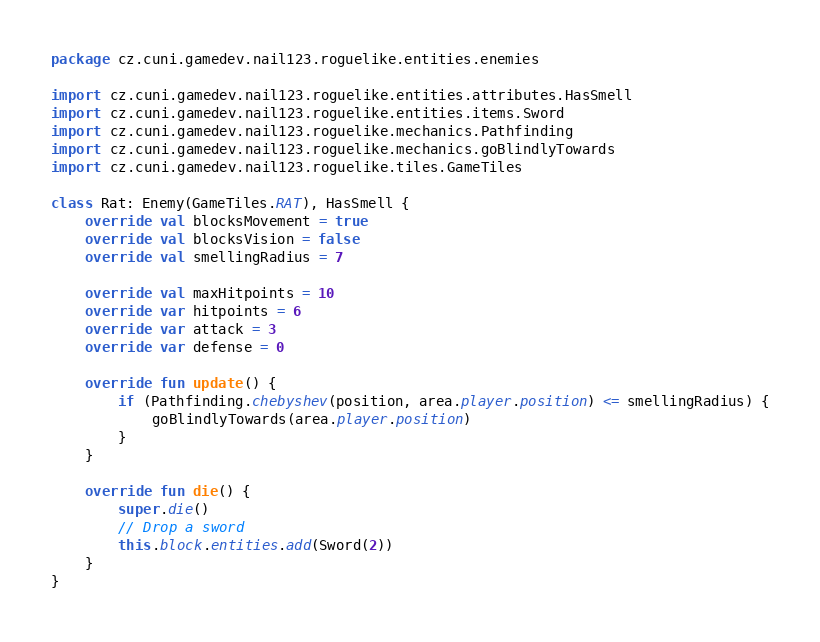Convert code to text. <code><loc_0><loc_0><loc_500><loc_500><_Kotlin_>package cz.cuni.gamedev.nail123.roguelike.entities.enemies

import cz.cuni.gamedev.nail123.roguelike.entities.attributes.HasSmell
import cz.cuni.gamedev.nail123.roguelike.entities.items.Sword
import cz.cuni.gamedev.nail123.roguelike.mechanics.Pathfinding
import cz.cuni.gamedev.nail123.roguelike.mechanics.goBlindlyTowards
import cz.cuni.gamedev.nail123.roguelike.tiles.GameTiles

class Rat: Enemy(GameTiles.RAT), HasSmell {
    override val blocksMovement = true
    override val blocksVision = false
    override val smellingRadius = 7

    override val maxHitpoints = 10
    override var hitpoints = 6
    override var attack = 3
    override var defense = 0

    override fun update() {
        if (Pathfinding.chebyshev(position, area.player.position) <= smellingRadius) {
            goBlindlyTowards(area.player.position)
        }
    }

    override fun die() {
        super.die()
        // Drop a sword
        this.block.entities.add(Sword(2))
    }
}</code> 